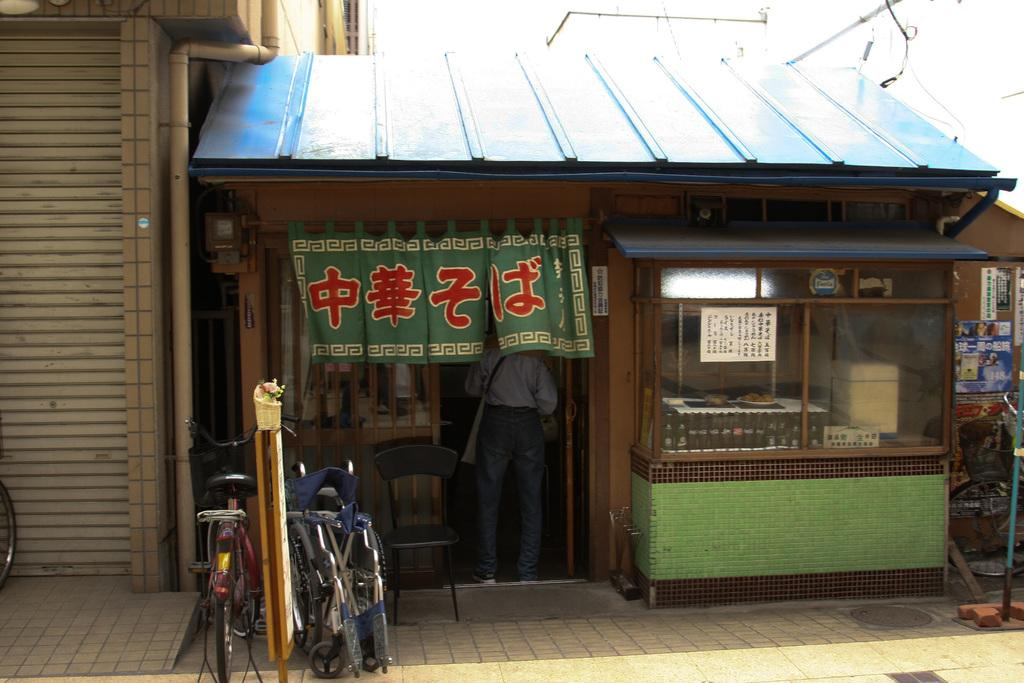What type of vehicles are in the image? There are bicycles in the image. Who is present in the image? There are people standing in the image. What piece of furniture can be seen in the image? There is a chair in the image. What type of establishment is visible in the image? There is a store in the image. What can be seen in the background of the image? There is a building in the background of the image. What type of songs can be heard coming from the bicycles in the image? There is no indication in the image that the bicycles are playing or producing any songs. What kind of arch is visible in the image? There is no arch present in the image. 